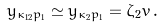Convert formula to latex. <formula><loc_0><loc_0><loc_500><loc_500>y _ { \kappa _ { 1 2 } p _ { 1 } } \simeq y _ { \kappa _ { 2 } p _ { 1 } } = \zeta _ { 2 } { \bar { v } } \, .</formula> 